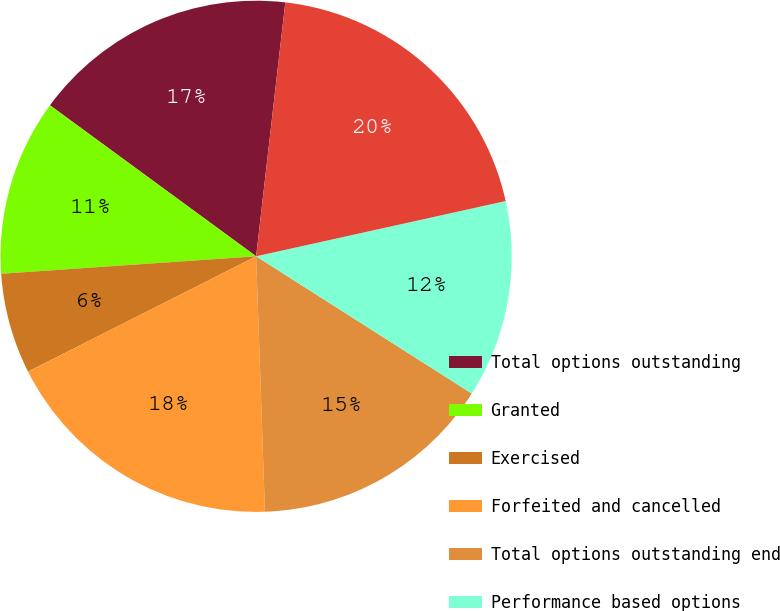Convert chart. <chart><loc_0><loc_0><loc_500><loc_500><pie_chart><fcel>Total options outstanding<fcel>Granted<fcel>Exercised<fcel>Forfeited and cancelled<fcel>Total options outstanding end<fcel>Performance based options<fcel>Exercisable at end of period<nl><fcel>16.76%<fcel>11.15%<fcel>6.36%<fcel>18.1%<fcel>15.43%<fcel>12.49%<fcel>19.71%<nl></chart> 